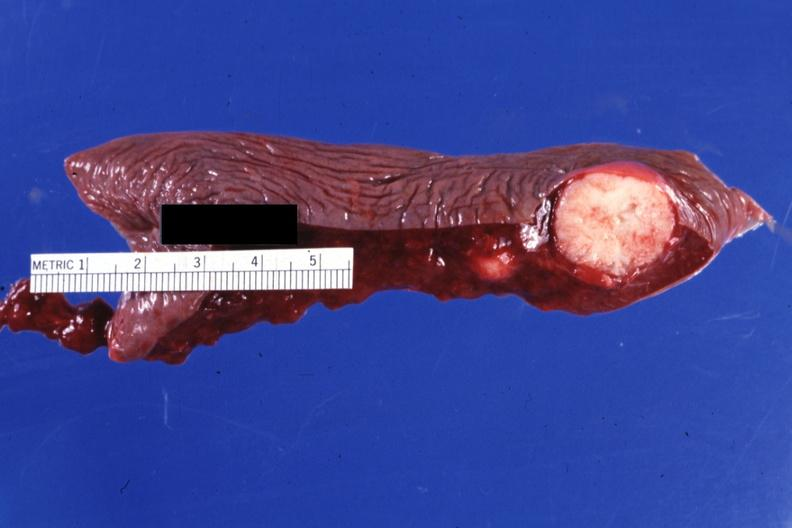does this image show cut surface typical?
Answer the question using a single word or phrase. Yes 